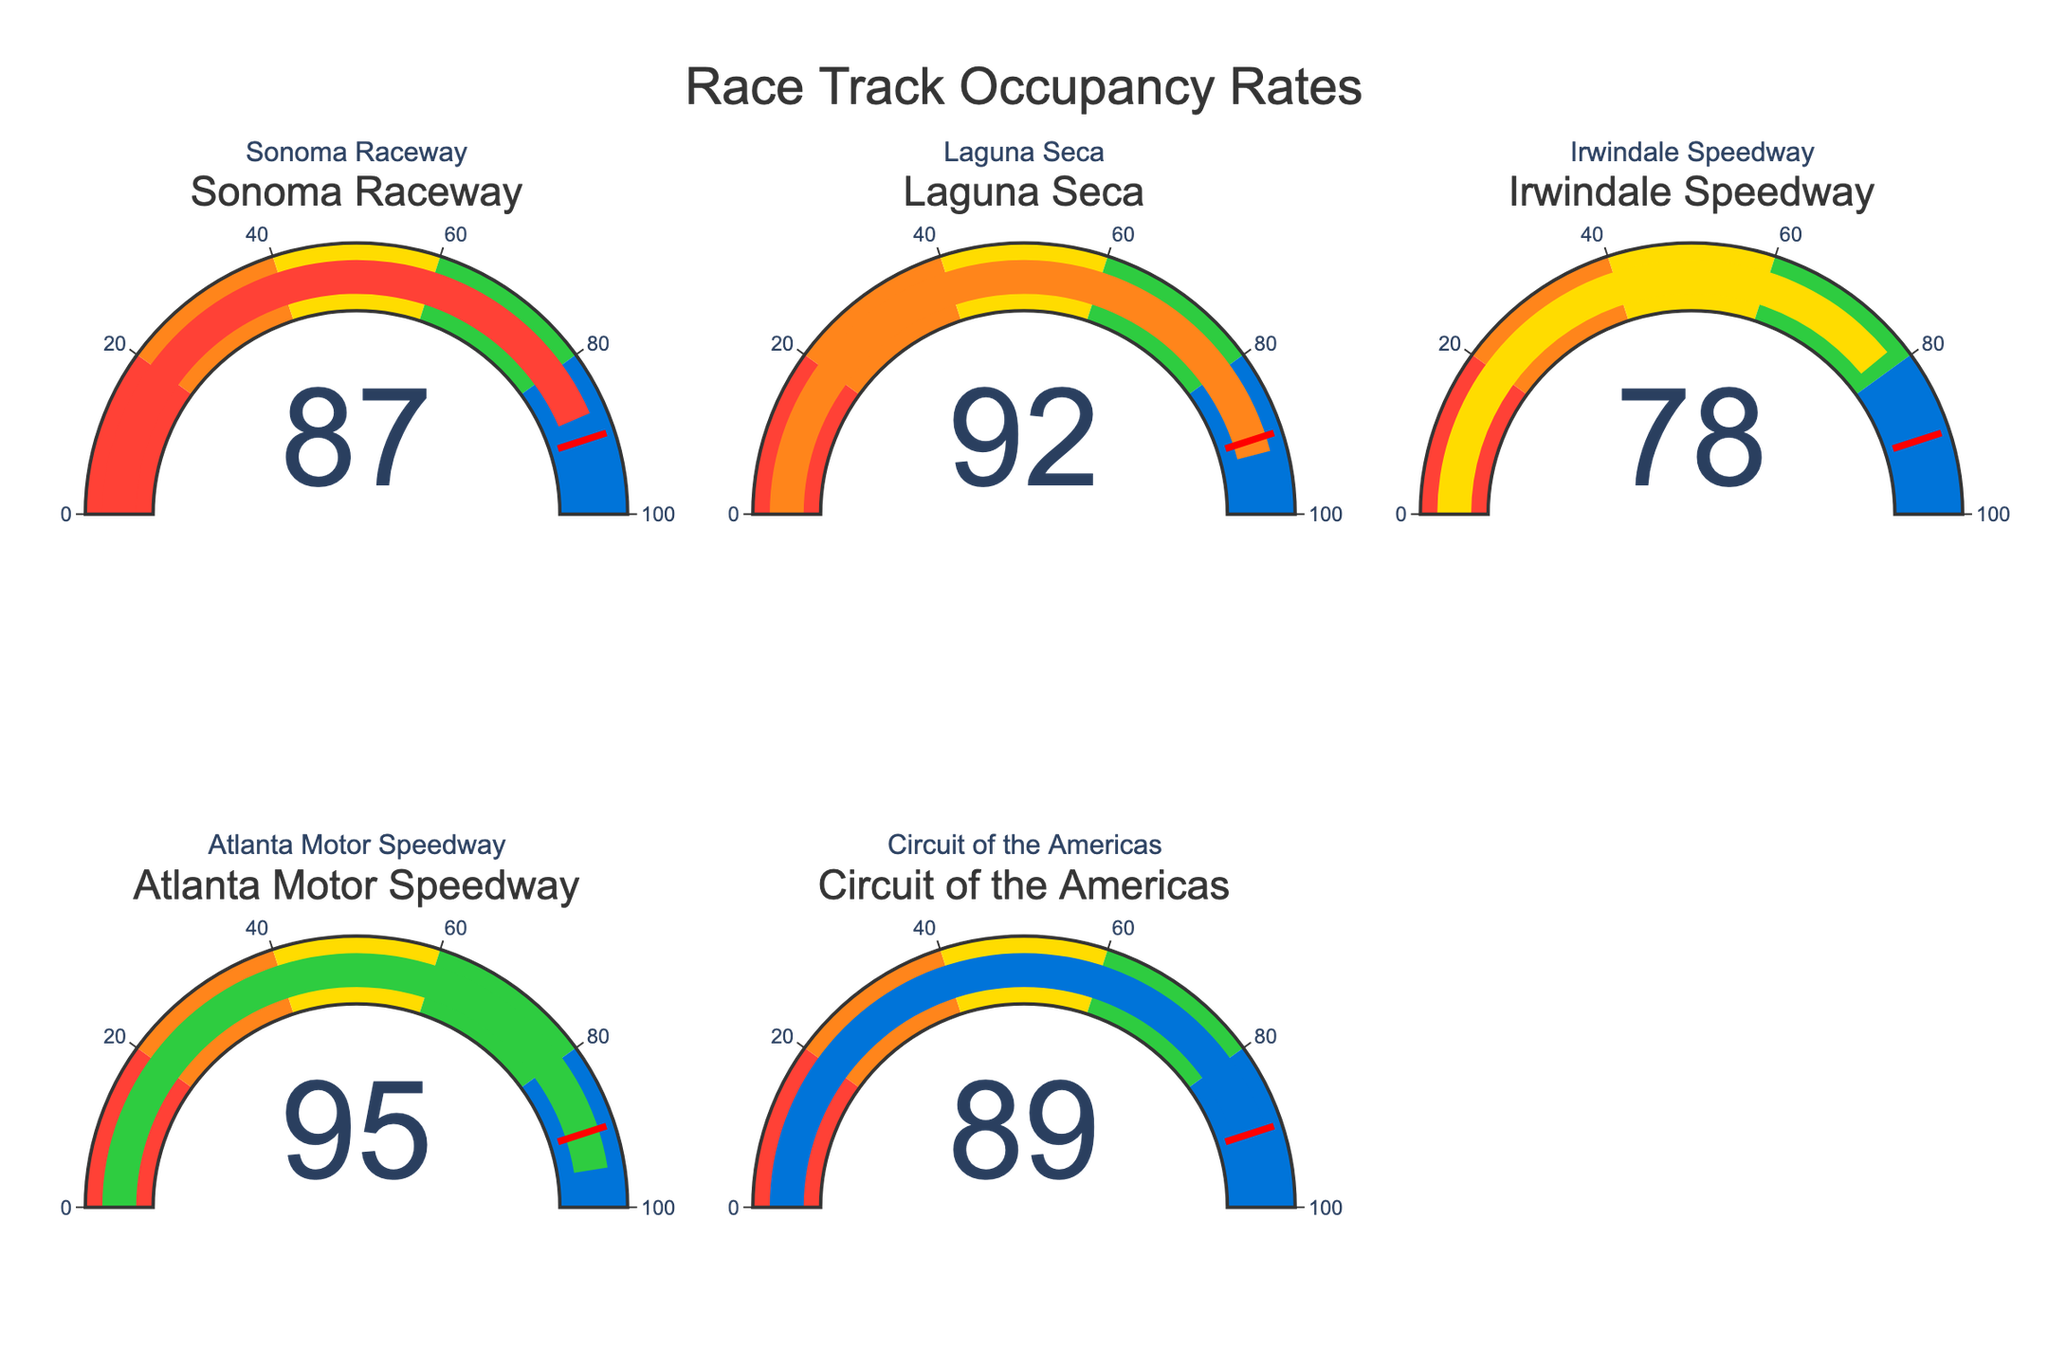What is the occupancy rate of Sonoma Raceway during peak hours? The gauge chart corresponding to Sonoma Raceway shows an occupancy rate of 87.
Answer: 87 Which track has the highest occupancy rate? By comparing all the gauge charts, the highest value visible is 95, which corresponds to the Atlanta Motor Speedway.
Answer: Atlanta Motor Speedway What is the average occupancy rate of the listed race tracks? Add up the occupancy rates (87 + 92 + 78 + 95 + 89) and divide by the number of tracks (5). The calculation results in an average of (441 / 5) = 88.2.
Answer: 88.2 Is the occupancy rate of Irwindale Speedway above or below 80? The gauge chart for Irwindale Speedway shows an occupancy rate of 78, which is below 80.
Answer: Below How many tracks have an occupancy rate above 90? Inspecting the gauge charts, both Laguna Seca (92) and Atlanta Motor Speedway (95) have occupancy rates above 90.
Answer: 2 Which track has more than 90% occupancy but less than 95%? Analyzing the charts, Laguna Seca has an occupancy of 92, which fits the criteria.
Answer: Laguna Seca What is the total occupancy rate of all the tracks combined? Sum the occupancy rates of all tracks: 87 + 92 + 78 + 95 + 89 = 441.
Answer: 441 What is the occupancy rate discrepancy between the highest and lowest occupied tracks? Subtract the lowest occupancy (78 from Irwindale Speedway) from the highest occupancy (95 from Atlanta Motor Speedway), resulting in a discrepancy of 17.
Answer: 17 Which track's occupancy is closest to the average occupancy rate of all tracks? The average occupancy rate is 88.2. Comparing this value with each track's occupancy, we see that Sonoma Raceway with an occupancy rate of 87 is the closest.
Answer: Sonoma Raceway 